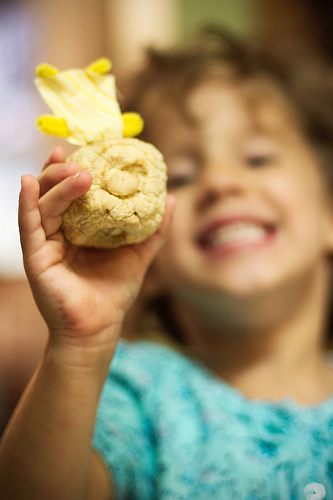<image>
Is the shirt on the skin? Yes. Looking at the image, I can see the shirt is positioned on top of the skin, with the skin providing support. 